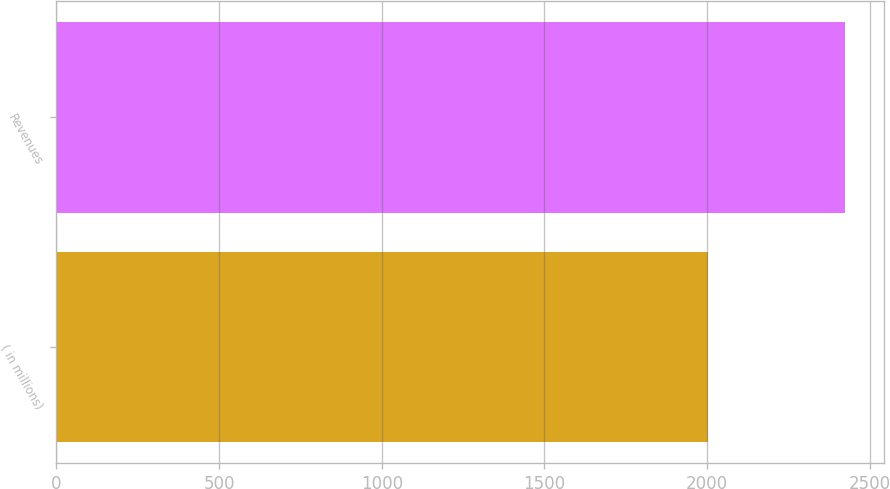Convert chart. <chart><loc_0><loc_0><loc_500><loc_500><bar_chart><fcel>( in millions)<fcel>Revenues<nl><fcel>2004<fcel>2423<nl></chart> 